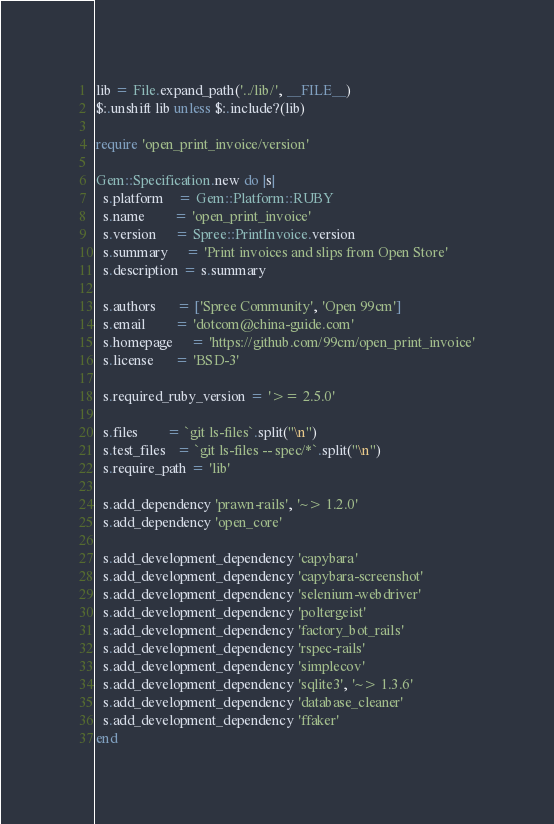Convert code to text. <code><loc_0><loc_0><loc_500><loc_500><_Ruby_>lib = File.expand_path('../lib/', __FILE__)
$:.unshift lib unless $:.include?(lib)

require 'open_print_invoice/version'

Gem::Specification.new do |s|
  s.platform    = Gem::Platform::RUBY
  s.name        = 'open_print_invoice'
  s.version     = Spree::PrintInvoice.version
  s.summary     = 'Print invoices and slips from Open Store'
  s.description = s.summary

  s.authors      = ['Spree Community', 'Open 99cm']
  s.email        = 'dotcom@china-guide.com'
  s.homepage     = 'https://github.com/99cm/open_print_invoice'
  s.license      = 'BSD-3'

  s.required_ruby_version = '>= 2.5.0'

  s.files        = `git ls-files`.split("\n")
  s.test_files   = `git ls-files -- spec/*`.split("\n")
  s.require_path = 'lib'

  s.add_dependency 'prawn-rails', '~> 1.2.0'
  s.add_dependency 'open_core'

  s.add_development_dependency 'capybara'
  s.add_development_dependency 'capybara-screenshot'
  s.add_development_dependency 'selenium-webdriver'
  s.add_development_dependency 'poltergeist'
  s.add_development_dependency 'factory_bot_rails'
  s.add_development_dependency 'rspec-rails'
  s.add_development_dependency 'simplecov'
  s.add_development_dependency 'sqlite3', '~> 1.3.6'
  s.add_development_dependency 'database_cleaner'
  s.add_development_dependency 'ffaker'
end</code> 